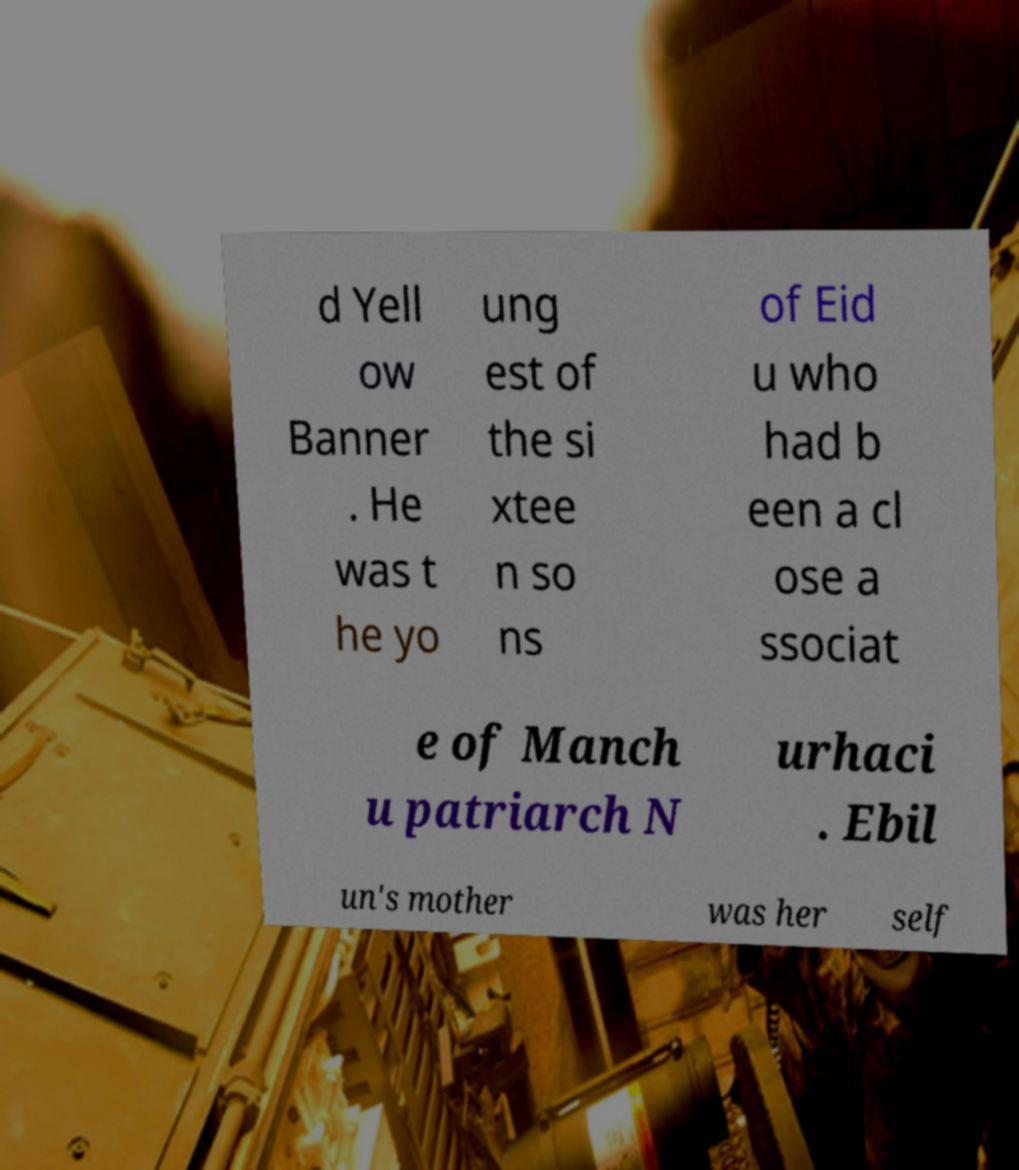Please read and relay the text visible in this image. What does it say? d Yell ow Banner . He was t he yo ung est of the si xtee n so ns of Eid u who had b een a cl ose a ssociat e of Manch u patriarch N urhaci . Ebil un's mother was her self 